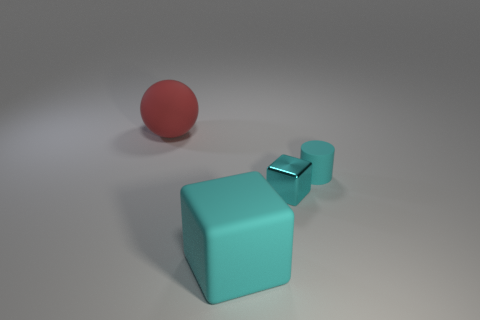What shape is the big object that is in front of the big matte thing left of the large matte thing in front of the matte ball?
Offer a terse response. Cube. There is a matte object that is on the right side of the big red rubber sphere and left of the small rubber cylinder; what is its color?
Provide a succinct answer. Cyan. There is a rubber object to the right of the metal thing; what shape is it?
Keep it short and to the point. Cylinder. There is a large red thing that is made of the same material as the cyan cylinder; what is its shape?
Provide a short and direct response. Sphere. How many shiny things are either balls or tiny cylinders?
Give a very brief answer. 0. There is a cube behind the big rubber object to the right of the red matte object; what number of big matte spheres are to the left of it?
Your answer should be very brief. 1. Does the cyan block that is left of the cyan metallic block have the same size as the cyan rubber object that is to the right of the small cyan metal block?
Make the answer very short. No. There is another object that is the same shape as the metallic object; what is its material?
Offer a very short reply. Rubber. What number of large objects are cyan cubes or red matte balls?
Your response must be concise. 2. What material is the tiny block?
Your response must be concise. Metal. 